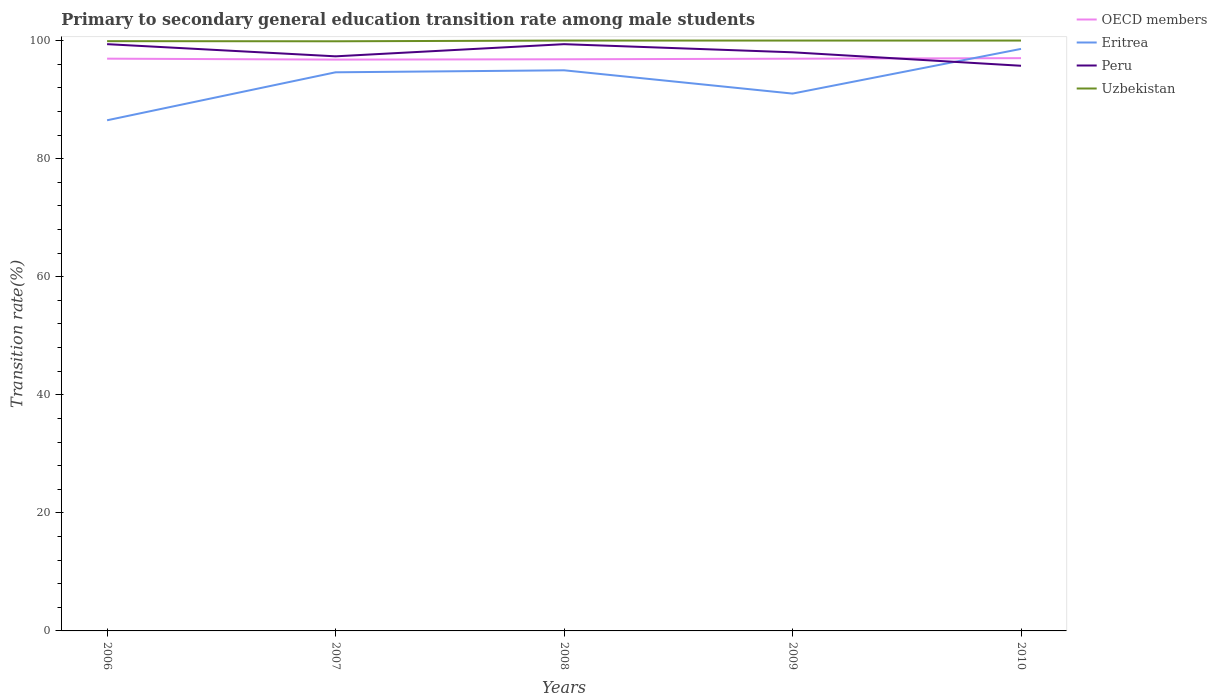How many different coloured lines are there?
Provide a short and direct response. 4. Does the line corresponding to OECD members intersect with the line corresponding to Eritrea?
Provide a short and direct response. Yes. Across all years, what is the maximum transition rate in Uzbekistan?
Offer a terse response. 99.88. What is the total transition rate in OECD members in the graph?
Your answer should be compact. -0.06. What is the difference between the highest and the second highest transition rate in Peru?
Give a very brief answer. 3.66. What is the difference between the highest and the lowest transition rate in Peru?
Provide a short and direct response. 3. Is the transition rate in OECD members strictly greater than the transition rate in Eritrea over the years?
Your response must be concise. No. How many lines are there?
Provide a succinct answer. 4. What is the difference between two consecutive major ticks on the Y-axis?
Offer a terse response. 20. Does the graph contain any zero values?
Provide a short and direct response. No. Does the graph contain grids?
Give a very brief answer. No. Where does the legend appear in the graph?
Give a very brief answer. Top right. How are the legend labels stacked?
Your answer should be very brief. Vertical. What is the title of the graph?
Your answer should be very brief. Primary to secondary general education transition rate among male students. Does "Korea (Republic)" appear as one of the legend labels in the graph?
Provide a short and direct response. No. What is the label or title of the X-axis?
Provide a succinct answer. Years. What is the label or title of the Y-axis?
Your answer should be compact. Transition rate(%). What is the Transition rate(%) of OECD members in 2006?
Your answer should be very brief. 96.93. What is the Transition rate(%) in Eritrea in 2006?
Your answer should be very brief. 86.5. What is the Transition rate(%) in Peru in 2006?
Your response must be concise. 99.39. What is the Transition rate(%) in Uzbekistan in 2006?
Keep it short and to the point. 99.9. What is the Transition rate(%) in OECD members in 2007?
Offer a very short reply. 96.78. What is the Transition rate(%) in Eritrea in 2007?
Your answer should be very brief. 94.62. What is the Transition rate(%) of Peru in 2007?
Give a very brief answer. 97.33. What is the Transition rate(%) of Uzbekistan in 2007?
Offer a very short reply. 99.88. What is the Transition rate(%) of OECD members in 2008?
Provide a succinct answer. 96.83. What is the Transition rate(%) in Eritrea in 2008?
Ensure brevity in your answer.  94.96. What is the Transition rate(%) in Peru in 2008?
Offer a very short reply. 99.39. What is the Transition rate(%) in Uzbekistan in 2008?
Offer a terse response. 100. What is the Transition rate(%) in OECD members in 2009?
Provide a succinct answer. 96.93. What is the Transition rate(%) in Eritrea in 2009?
Give a very brief answer. 91.02. What is the Transition rate(%) in Peru in 2009?
Offer a very short reply. 98.01. What is the Transition rate(%) of Uzbekistan in 2009?
Give a very brief answer. 100. What is the Transition rate(%) in OECD members in 2010?
Keep it short and to the point. 97.02. What is the Transition rate(%) of Eritrea in 2010?
Your answer should be compact. 98.59. What is the Transition rate(%) of Peru in 2010?
Your answer should be compact. 95.73. What is the Transition rate(%) of Uzbekistan in 2010?
Give a very brief answer. 100. Across all years, what is the maximum Transition rate(%) of OECD members?
Provide a succinct answer. 97.02. Across all years, what is the maximum Transition rate(%) in Eritrea?
Make the answer very short. 98.59. Across all years, what is the maximum Transition rate(%) in Peru?
Offer a terse response. 99.39. Across all years, what is the maximum Transition rate(%) of Uzbekistan?
Offer a terse response. 100. Across all years, what is the minimum Transition rate(%) of OECD members?
Your answer should be compact. 96.78. Across all years, what is the minimum Transition rate(%) of Eritrea?
Keep it short and to the point. 86.5. Across all years, what is the minimum Transition rate(%) in Peru?
Your answer should be compact. 95.73. Across all years, what is the minimum Transition rate(%) in Uzbekistan?
Provide a succinct answer. 99.88. What is the total Transition rate(%) in OECD members in the graph?
Your answer should be compact. 484.49. What is the total Transition rate(%) of Eritrea in the graph?
Give a very brief answer. 465.69. What is the total Transition rate(%) in Peru in the graph?
Your response must be concise. 489.85. What is the total Transition rate(%) in Uzbekistan in the graph?
Provide a succinct answer. 499.78. What is the difference between the Transition rate(%) of OECD members in 2006 and that in 2007?
Your answer should be very brief. 0.16. What is the difference between the Transition rate(%) in Eritrea in 2006 and that in 2007?
Ensure brevity in your answer.  -8.13. What is the difference between the Transition rate(%) in Peru in 2006 and that in 2007?
Make the answer very short. 2.06. What is the difference between the Transition rate(%) of Uzbekistan in 2006 and that in 2007?
Offer a terse response. 0.02. What is the difference between the Transition rate(%) in OECD members in 2006 and that in 2008?
Provide a succinct answer. 0.1. What is the difference between the Transition rate(%) of Eritrea in 2006 and that in 2008?
Keep it short and to the point. -8.47. What is the difference between the Transition rate(%) in Peru in 2006 and that in 2008?
Offer a very short reply. 0. What is the difference between the Transition rate(%) of Uzbekistan in 2006 and that in 2008?
Make the answer very short. -0.1. What is the difference between the Transition rate(%) of OECD members in 2006 and that in 2009?
Your answer should be very brief. 0.01. What is the difference between the Transition rate(%) of Eritrea in 2006 and that in 2009?
Your response must be concise. -4.52. What is the difference between the Transition rate(%) of Peru in 2006 and that in 2009?
Offer a terse response. 1.38. What is the difference between the Transition rate(%) in Uzbekistan in 2006 and that in 2009?
Offer a terse response. -0.1. What is the difference between the Transition rate(%) of OECD members in 2006 and that in 2010?
Offer a very short reply. -0.09. What is the difference between the Transition rate(%) of Eritrea in 2006 and that in 2010?
Your answer should be very brief. -12.09. What is the difference between the Transition rate(%) of Peru in 2006 and that in 2010?
Provide a short and direct response. 3.66. What is the difference between the Transition rate(%) in Uzbekistan in 2006 and that in 2010?
Provide a short and direct response. -0.1. What is the difference between the Transition rate(%) of OECD members in 2007 and that in 2008?
Give a very brief answer. -0.06. What is the difference between the Transition rate(%) in Eritrea in 2007 and that in 2008?
Your answer should be compact. -0.34. What is the difference between the Transition rate(%) of Peru in 2007 and that in 2008?
Give a very brief answer. -2.06. What is the difference between the Transition rate(%) of Uzbekistan in 2007 and that in 2008?
Give a very brief answer. -0.12. What is the difference between the Transition rate(%) of OECD members in 2007 and that in 2009?
Your answer should be compact. -0.15. What is the difference between the Transition rate(%) in Eritrea in 2007 and that in 2009?
Give a very brief answer. 3.61. What is the difference between the Transition rate(%) in Peru in 2007 and that in 2009?
Your answer should be compact. -0.68. What is the difference between the Transition rate(%) in Uzbekistan in 2007 and that in 2009?
Keep it short and to the point. -0.12. What is the difference between the Transition rate(%) in OECD members in 2007 and that in 2010?
Offer a terse response. -0.25. What is the difference between the Transition rate(%) of Eritrea in 2007 and that in 2010?
Provide a succinct answer. -3.96. What is the difference between the Transition rate(%) in Peru in 2007 and that in 2010?
Offer a very short reply. 1.6. What is the difference between the Transition rate(%) in Uzbekistan in 2007 and that in 2010?
Make the answer very short. -0.12. What is the difference between the Transition rate(%) of OECD members in 2008 and that in 2009?
Ensure brevity in your answer.  -0.1. What is the difference between the Transition rate(%) in Eritrea in 2008 and that in 2009?
Your answer should be compact. 3.95. What is the difference between the Transition rate(%) in Peru in 2008 and that in 2009?
Your answer should be very brief. 1.38. What is the difference between the Transition rate(%) of OECD members in 2008 and that in 2010?
Your answer should be compact. -0.19. What is the difference between the Transition rate(%) in Eritrea in 2008 and that in 2010?
Ensure brevity in your answer.  -3.62. What is the difference between the Transition rate(%) of Peru in 2008 and that in 2010?
Offer a terse response. 3.66. What is the difference between the Transition rate(%) of OECD members in 2009 and that in 2010?
Your answer should be very brief. -0.09. What is the difference between the Transition rate(%) in Eritrea in 2009 and that in 2010?
Offer a very short reply. -7.57. What is the difference between the Transition rate(%) of Peru in 2009 and that in 2010?
Make the answer very short. 2.28. What is the difference between the Transition rate(%) of Uzbekistan in 2009 and that in 2010?
Provide a succinct answer. 0. What is the difference between the Transition rate(%) of OECD members in 2006 and the Transition rate(%) of Eritrea in 2007?
Make the answer very short. 2.31. What is the difference between the Transition rate(%) in OECD members in 2006 and the Transition rate(%) in Peru in 2007?
Offer a terse response. -0.39. What is the difference between the Transition rate(%) of OECD members in 2006 and the Transition rate(%) of Uzbekistan in 2007?
Provide a short and direct response. -2.94. What is the difference between the Transition rate(%) of Eritrea in 2006 and the Transition rate(%) of Peru in 2007?
Offer a very short reply. -10.83. What is the difference between the Transition rate(%) of Eritrea in 2006 and the Transition rate(%) of Uzbekistan in 2007?
Your answer should be compact. -13.38. What is the difference between the Transition rate(%) in Peru in 2006 and the Transition rate(%) in Uzbekistan in 2007?
Provide a succinct answer. -0.49. What is the difference between the Transition rate(%) in OECD members in 2006 and the Transition rate(%) in Eritrea in 2008?
Keep it short and to the point. 1.97. What is the difference between the Transition rate(%) of OECD members in 2006 and the Transition rate(%) of Peru in 2008?
Give a very brief answer. -2.45. What is the difference between the Transition rate(%) of OECD members in 2006 and the Transition rate(%) of Uzbekistan in 2008?
Provide a succinct answer. -3.07. What is the difference between the Transition rate(%) in Eritrea in 2006 and the Transition rate(%) in Peru in 2008?
Make the answer very short. -12.89. What is the difference between the Transition rate(%) of Eritrea in 2006 and the Transition rate(%) of Uzbekistan in 2008?
Ensure brevity in your answer.  -13.5. What is the difference between the Transition rate(%) in Peru in 2006 and the Transition rate(%) in Uzbekistan in 2008?
Provide a succinct answer. -0.61. What is the difference between the Transition rate(%) of OECD members in 2006 and the Transition rate(%) of Eritrea in 2009?
Your response must be concise. 5.92. What is the difference between the Transition rate(%) of OECD members in 2006 and the Transition rate(%) of Peru in 2009?
Your answer should be very brief. -1.08. What is the difference between the Transition rate(%) of OECD members in 2006 and the Transition rate(%) of Uzbekistan in 2009?
Give a very brief answer. -3.07. What is the difference between the Transition rate(%) in Eritrea in 2006 and the Transition rate(%) in Peru in 2009?
Provide a short and direct response. -11.51. What is the difference between the Transition rate(%) in Eritrea in 2006 and the Transition rate(%) in Uzbekistan in 2009?
Offer a terse response. -13.5. What is the difference between the Transition rate(%) of Peru in 2006 and the Transition rate(%) of Uzbekistan in 2009?
Provide a short and direct response. -0.61. What is the difference between the Transition rate(%) in OECD members in 2006 and the Transition rate(%) in Eritrea in 2010?
Your answer should be compact. -1.65. What is the difference between the Transition rate(%) in OECD members in 2006 and the Transition rate(%) in Peru in 2010?
Keep it short and to the point. 1.21. What is the difference between the Transition rate(%) of OECD members in 2006 and the Transition rate(%) of Uzbekistan in 2010?
Give a very brief answer. -3.07. What is the difference between the Transition rate(%) in Eritrea in 2006 and the Transition rate(%) in Peru in 2010?
Provide a succinct answer. -9.23. What is the difference between the Transition rate(%) of Eritrea in 2006 and the Transition rate(%) of Uzbekistan in 2010?
Offer a terse response. -13.5. What is the difference between the Transition rate(%) of Peru in 2006 and the Transition rate(%) of Uzbekistan in 2010?
Keep it short and to the point. -0.61. What is the difference between the Transition rate(%) of OECD members in 2007 and the Transition rate(%) of Eritrea in 2008?
Provide a short and direct response. 1.81. What is the difference between the Transition rate(%) in OECD members in 2007 and the Transition rate(%) in Peru in 2008?
Offer a very short reply. -2.61. What is the difference between the Transition rate(%) of OECD members in 2007 and the Transition rate(%) of Uzbekistan in 2008?
Keep it short and to the point. -3.22. What is the difference between the Transition rate(%) of Eritrea in 2007 and the Transition rate(%) of Peru in 2008?
Your response must be concise. -4.76. What is the difference between the Transition rate(%) of Eritrea in 2007 and the Transition rate(%) of Uzbekistan in 2008?
Provide a succinct answer. -5.38. What is the difference between the Transition rate(%) of Peru in 2007 and the Transition rate(%) of Uzbekistan in 2008?
Make the answer very short. -2.67. What is the difference between the Transition rate(%) in OECD members in 2007 and the Transition rate(%) in Eritrea in 2009?
Your response must be concise. 5.76. What is the difference between the Transition rate(%) in OECD members in 2007 and the Transition rate(%) in Peru in 2009?
Your response must be concise. -1.24. What is the difference between the Transition rate(%) of OECD members in 2007 and the Transition rate(%) of Uzbekistan in 2009?
Provide a succinct answer. -3.22. What is the difference between the Transition rate(%) of Eritrea in 2007 and the Transition rate(%) of Peru in 2009?
Keep it short and to the point. -3.39. What is the difference between the Transition rate(%) in Eritrea in 2007 and the Transition rate(%) in Uzbekistan in 2009?
Ensure brevity in your answer.  -5.38. What is the difference between the Transition rate(%) of Peru in 2007 and the Transition rate(%) of Uzbekistan in 2009?
Keep it short and to the point. -2.67. What is the difference between the Transition rate(%) in OECD members in 2007 and the Transition rate(%) in Eritrea in 2010?
Offer a terse response. -1.81. What is the difference between the Transition rate(%) in OECD members in 2007 and the Transition rate(%) in Peru in 2010?
Offer a very short reply. 1.05. What is the difference between the Transition rate(%) of OECD members in 2007 and the Transition rate(%) of Uzbekistan in 2010?
Provide a succinct answer. -3.22. What is the difference between the Transition rate(%) in Eritrea in 2007 and the Transition rate(%) in Peru in 2010?
Offer a very short reply. -1.11. What is the difference between the Transition rate(%) of Eritrea in 2007 and the Transition rate(%) of Uzbekistan in 2010?
Make the answer very short. -5.38. What is the difference between the Transition rate(%) in Peru in 2007 and the Transition rate(%) in Uzbekistan in 2010?
Provide a succinct answer. -2.67. What is the difference between the Transition rate(%) of OECD members in 2008 and the Transition rate(%) of Eritrea in 2009?
Offer a very short reply. 5.81. What is the difference between the Transition rate(%) of OECD members in 2008 and the Transition rate(%) of Peru in 2009?
Ensure brevity in your answer.  -1.18. What is the difference between the Transition rate(%) in OECD members in 2008 and the Transition rate(%) in Uzbekistan in 2009?
Offer a terse response. -3.17. What is the difference between the Transition rate(%) in Eritrea in 2008 and the Transition rate(%) in Peru in 2009?
Provide a succinct answer. -3.05. What is the difference between the Transition rate(%) of Eritrea in 2008 and the Transition rate(%) of Uzbekistan in 2009?
Offer a terse response. -5.04. What is the difference between the Transition rate(%) in Peru in 2008 and the Transition rate(%) in Uzbekistan in 2009?
Give a very brief answer. -0.61. What is the difference between the Transition rate(%) of OECD members in 2008 and the Transition rate(%) of Eritrea in 2010?
Your answer should be very brief. -1.76. What is the difference between the Transition rate(%) of OECD members in 2008 and the Transition rate(%) of Peru in 2010?
Provide a succinct answer. 1.1. What is the difference between the Transition rate(%) in OECD members in 2008 and the Transition rate(%) in Uzbekistan in 2010?
Offer a terse response. -3.17. What is the difference between the Transition rate(%) in Eritrea in 2008 and the Transition rate(%) in Peru in 2010?
Keep it short and to the point. -0.77. What is the difference between the Transition rate(%) of Eritrea in 2008 and the Transition rate(%) of Uzbekistan in 2010?
Your response must be concise. -5.04. What is the difference between the Transition rate(%) in Peru in 2008 and the Transition rate(%) in Uzbekistan in 2010?
Provide a short and direct response. -0.61. What is the difference between the Transition rate(%) of OECD members in 2009 and the Transition rate(%) of Eritrea in 2010?
Provide a short and direct response. -1.66. What is the difference between the Transition rate(%) in OECD members in 2009 and the Transition rate(%) in Peru in 2010?
Keep it short and to the point. 1.2. What is the difference between the Transition rate(%) of OECD members in 2009 and the Transition rate(%) of Uzbekistan in 2010?
Your answer should be compact. -3.07. What is the difference between the Transition rate(%) of Eritrea in 2009 and the Transition rate(%) of Peru in 2010?
Make the answer very short. -4.71. What is the difference between the Transition rate(%) of Eritrea in 2009 and the Transition rate(%) of Uzbekistan in 2010?
Your answer should be compact. -8.98. What is the difference between the Transition rate(%) in Peru in 2009 and the Transition rate(%) in Uzbekistan in 2010?
Offer a very short reply. -1.99. What is the average Transition rate(%) in OECD members per year?
Ensure brevity in your answer.  96.9. What is the average Transition rate(%) in Eritrea per year?
Provide a short and direct response. 93.14. What is the average Transition rate(%) in Peru per year?
Offer a terse response. 97.97. What is the average Transition rate(%) of Uzbekistan per year?
Provide a succinct answer. 99.96. In the year 2006, what is the difference between the Transition rate(%) of OECD members and Transition rate(%) of Eritrea?
Your response must be concise. 10.44. In the year 2006, what is the difference between the Transition rate(%) of OECD members and Transition rate(%) of Peru?
Offer a terse response. -2.46. In the year 2006, what is the difference between the Transition rate(%) of OECD members and Transition rate(%) of Uzbekistan?
Give a very brief answer. -2.97. In the year 2006, what is the difference between the Transition rate(%) in Eritrea and Transition rate(%) in Peru?
Provide a succinct answer. -12.89. In the year 2006, what is the difference between the Transition rate(%) in Eritrea and Transition rate(%) in Uzbekistan?
Give a very brief answer. -13.4. In the year 2006, what is the difference between the Transition rate(%) in Peru and Transition rate(%) in Uzbekistan?
Offer a terse response. -0.51. In the year 2007, what is the difference between the Transition rate(%) in OECD members and Transition rate(%) in Eritrea?
Keep it short and to the point. 2.15. In the year 2007, what is the difference between the Transition rate(%) in OECD members and Transition rate(%) in Peru?
Your response must be concise. -0.55. In the year 2007, what is the difference between the Transition rate(%) of OECD members and Transition rate(%) of Uzbekistan?
Give a very brief answer. -3.1. In the year 2007, what is the difference between the Transition rate(%) in Eritrea and Transition rate(%) in Peru?
Ensure brevity in your answer.  -2.7. In the year 2007, what is the difference between the Transition rate(%) in Eritrea and Transition rate(%) in Uzbekistan?
Your answer should be compact. -5.25. In the year 2007, what is the difference between the Transition rate(%) in Peru and Transition rate(%) in Uzbekistan?
Your response must be concise. -2.55. In the year 2008, what is the difference between the Transition rate(%) of OECD members and Transition rate(%) of Eritrea?
Your response must be concise. 1.87. In the year 2008, what is the difference between the Transition rate(%) in OECD members and Transition rate(%) in Peru?
Your answer should be very brief. -2.56. In the year 2008, what is the difference between the Transition rate(%) in OECD members and Transition rate(%) in Uzbekistan?
Provide a succinct answer. -3.17. In the year 2008, what is the difference between the Transition rate(%) in Eritrea and Transition rate(%) in Peru?
Provide a short and direct response. -4.42. In the year 2008, what is the difference between the Transition rate(%) in Eritrea and Transition rate(%) in Uzbekistan?
Your response must be concise. -5.04. In the year 2008, what is the difference between the Transition rate(%) of Peru and Transition rate(%) of Uzbekistan?
Your response must be concise. -0.61. In the year 2009, what is the difference between the Transition rate(%) of OECD members and Transition rate(%) of Eritrea?
Make the answer very short. 5.91. In the year 2009, what is the difference between the Transition rate(%) of OECD members and Transition rate(%) of Peru?
Make the answer very short. -1.09. In the year 2009, what is the difference between the Transition rate(%) in OECD members and Transition rate(%) in Uzbekistan?
Your response must be concise. -3.07. In the year 2009, what is the difference between the Transition rate(%) in Eritrea and Transition rate(%) in Peru?
Your response must be concise. -6.99. In the year 2009, what is the difference between the Transition rate(%) of Eritrea and Transition rate(%) of Uzbekistan?
Your answer should be compact. -8.98. In the year 2009, what is the difference between the Transition rate(%) in Peru and Transition rate(%) in Uzbekistan?
Ensure brevity in your answer.  -1.99. In the year 2010, what is the difference between the Transition rate(%) in OECD members and Transition rate(%) in Eritrea?
Provide a short and direct response. -1.57. In the year 2010, what is the difference between the Transition rate(%) in OECD members and Transition rate(%) in Peru?
Provide a short and direct response. 1.29. In the year 2010, what is the difference between the Transition rate(%) in OECD members and Transition rate(%) in Uzbekistan?
Make the answer very short. -2.98. In the year 2010, what is the difference between the Transition rate(%) of Eritrea and Transition rate(%) of Peru?
Your answer should be compact. 2.86. In the year 2010, what is the difference between the Transition rate(%) in Eritrea and Transition rate(%) in Uzbekistan?
Your response must be concise. -1.41. In the year 2010, what is the difference between the Transition rate(%) in Peru and Transition rate(%) in Uzbekistan?
Provide a succinct answer. -4.27. What is the ratio of the Transition rate(%) of OECD members in 2006 to that in 2007?
Give a very brief answer. 1. What is the ratio of the Transition rate(%) of Eritrea in 2006 to that in 2007?
Ensure brevity in your answer.  0.91. What is the ratio of the Transition rate(%) of Peru in 2006 to that in 2007?
Your answer should be very brief. 1.02. What is the ratio of the Transition rate(%) of Uzbekistan in 2006 to that in 2007?
Ensure brevity in your answer.  1. What is the ratio of the Transition rate(%) in Eritrea in 2006 to that in 2008?
Provide a short and direct response. 0.91. What is the ratio of the Transition rate(%) in Peru in 2006 to that in 2008?
Give a very brief answer. 1. What is the ratio of the Transition rate(%) of Eritrea in 2006 to that in 2009?
Make the answer very short. 0.95. What is the ratio of the Transition rate(%) in Peru in 2006 to that in 2009?
Your answer should be compact. 1.01. What is the ratio of the Transition rate(%) of OECD members in 2006 to that in 2010?
Ensure brevity in your answer.  1. What is the ratio of the Transition rate(%) of Eritrea in 2006 to that in 2010?
Offer a very short reply. 0.88. What is the ratio of the Transition rate(%) in Peru in 2006 to that in 2010?
Your answer should be compact. 1.04. What is the ratio of the Transition rate(%) in Eritrea in 2007 to that in 2008?
Provide a short and direct response. 1. What is the ratio of the Transition rate(%) of Peru in 2007 to that in 2008?
Ensure brevity in your answer.  0.98. What is the ratio of the Transition rate(%) of OECD members in 2007 to that in 2009?
Give a very brief answer. 1. What is the ratio of the Transition rate(%) of Eritrea in 2007 to that in 2009?
Provide a succinct answer. 1.04. What is the ratio of the Transition rate(%) of Peru in 2007 to that in 2009?
Make the answer very short. 0.99. What is the ratio of the Transition rate(%) of Eritrea in 2007 to that in 2010?
Offer a very short reply. 0.96. What is the ratio of the Transition rate(%) of Peru in 2007 to that in 2010?
Ensure brevity in your answer.  1.02. What is the ratio of the Transition rate(%) of OECD members in 2008 to that in 2009?
Your answer should be compact. 1. What is the ratio of the Transition rate(%) in Eritrea in 2008 to that in 2009?
Give a very brief answer. 1.04. What is the ratio of the Transition rate(%) of Peru in 2008 to that in 2009?
Provide a short and direct response. 1.01. What is the ratio of the Transition rate(%) of OECD members in 2008 to that in 2010?
Offer a terse response. 1. What is the ratio of the Transition rate(%) of Eritrea in 2008 to that in 2010?
Your answer should be compact. 0.96. What is the ratio of the Transition rate(%) of Peru in 2008 to that in 2010?
Offer a very short reply. 1.04. What is the ratio of the Transition rate(%) of Uzbekistan in 2008 to that in 2010?
Offer a terse response. 1. What is the ratio of the Transition rate(%) of Eritrea in 2009 to that in 2010?
Your answer should be very brief. 0.92. What is the ratio of the Transition rate(%) in Peru in 2009 to that in 2010?
Make the answer very short. 1.02. What is the difference between the highest and the second highest Transition rate(%) in OECD members?
Provide a short and direct response. 0.09. What is the difference between the highest and the second highest Transition rate(%) in Eritrea?
Provide a short and direct response. 3.62. What is the difference between the highest and the second highest Transition rate(%) of Peru?
Keep it short and to the point. 0. What is the difference between the highest and the second highest Transition rate(%) in Uzbekistan?
Your answer should be compact. 0. What is the difference between the highest and the lowest Transition rate(%) in OECD members?
Make the answer very short. 0.25. What is the difference between the highest and the lowest Transition rate(%) of Eritrea?
Give a very brief answer. 12.09. What is the difference between the highest and the lowest Transition rate(%) in Peru?
Your answer should be compact. 3.66. What is the difference between the highest and the lowest Transition rate(%) of Uzbekistan?
Your answer should be compact. 0.12. 